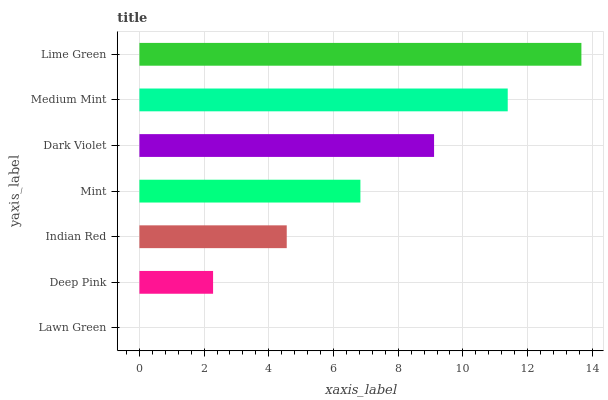Is Lawn Green the minimum?
Answer yes or no. Yes. Is Lime Green the maximum?
Answer yes or no. Yes. Is Deep Pink the minimum?
Answer yes or no. No. Is Deep Pink the maximum?
Answer yes or no. No. Is Deep Pink greater than Lawn Green?
Answer yes or no. Yes. Is Lawn Green less than Deep Pink?
Answer yes or no. Yes. Is Lawn Green greater than Deep Pink?
Answer yes or no. No. Is Deep Pink less than Lawn Green?
Answer yes or no. No. Is Mint the high median?
Answer yes or no. Yes. Is Mint the low median?
Answer yes or no. Yes. Is Indian Red the high median?
Answer yes or no. No. Is Dark Violet the low median?
Answer yes or no. No. 